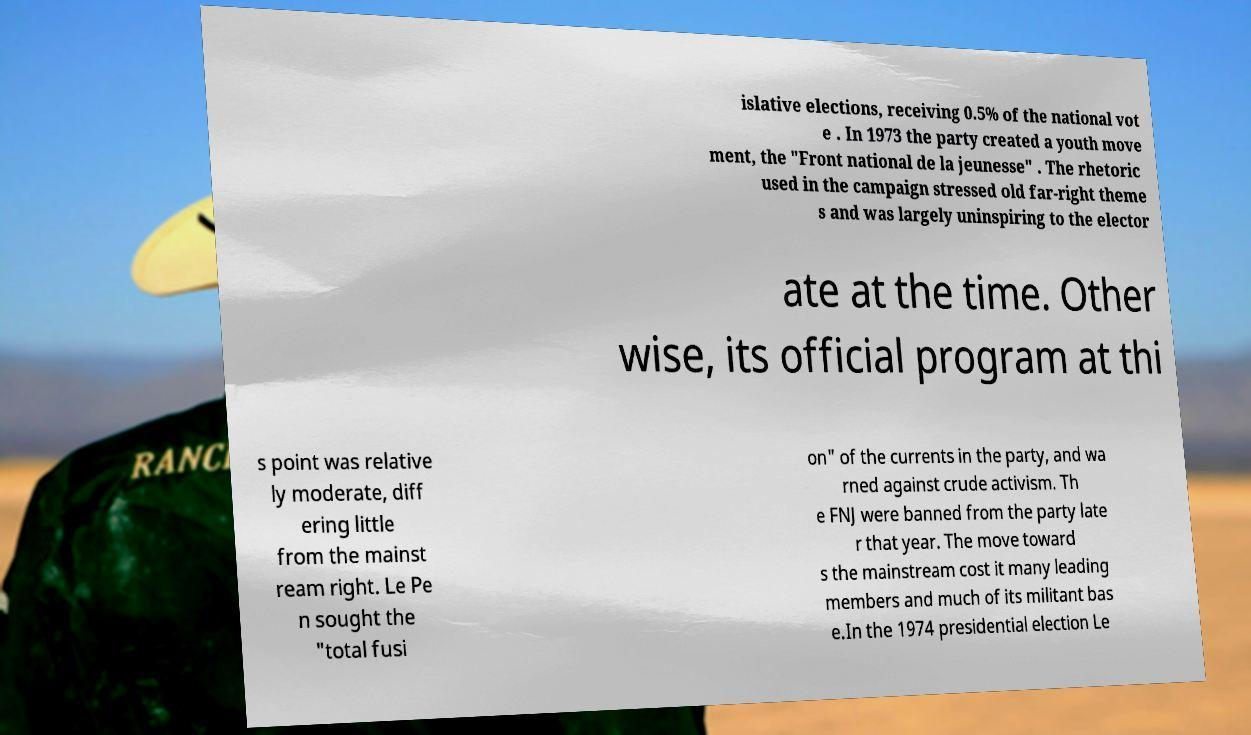Could you extract and type out the text from this image? islative elections, receiving 0.5% of the national vot e . In 1973 the party created a youth move ment, the "Front national de la jeunesse" . The rhetoric used in the campaign stressed old far-right theme s and was largely uninspiring to the elector ate at the time. Other wise, its official program at thi s point was relative ly moderate, diff ering little from the mainst ream right. Le Pe n sought the "total fusi on" of the currents in the party, and wa rned against crude activism. Th e FNJ were banned from the party late r that year. The move toward s the mainstream cost it many leading members and much of its militant bas e.In the 1974 presidential election Le 